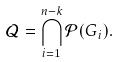Convert formula to latex. <formula><loc_0><loc_0><loc_500><loc_500>\mathcal { Q } = \bigcap _ { i = 1 } ^ { n - k } \mathcal { P } ( G _ { i } ) .</formula> 